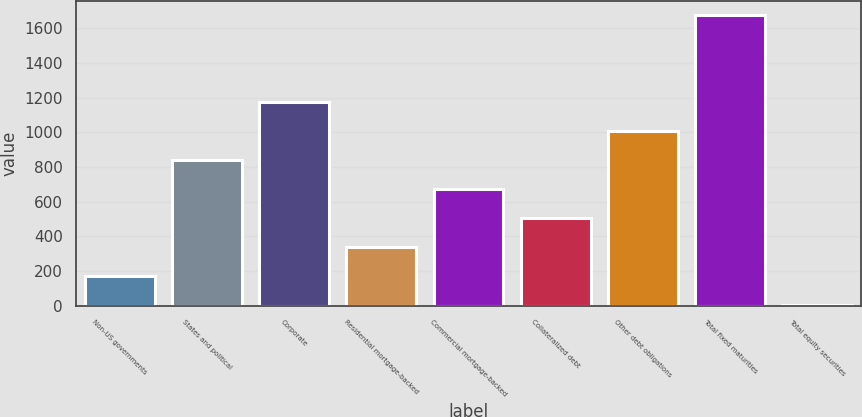Convert chart to OTSL. <chart><loc_0><loc_0><loc_500><loc_500><bar_chart><fcel>Non-US governments<fcel>States and political<fcel>Corporate<fcel>Residential mortgage-backed<fcel>Commercial mortgage-backed<fcel>Collateralized debt<fcel>Other debt obligations<fcel>Total fixed maturities<fcel>Total equity securities<nl><fcel>172.91<fcel>841.35<fcel>1175.57<fcel>340.02<fcel>674.24<fcel>507.13<fcel>1008.46<fcel>1676.9<fcel>5.8<nl></chart> 